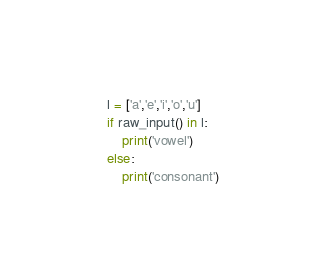<code> <loc_0><loc_0><loc_500><loc_500><_Python_>l = ['a','e','i','o','u']
if raw_input() in l:
	print('vowel')
else:
	print('consonant')</code> 